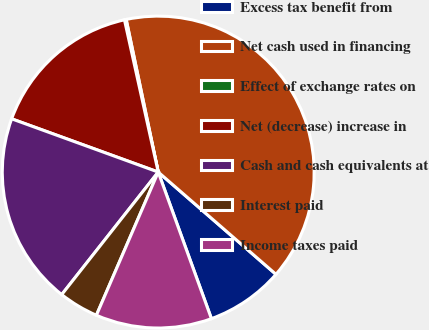Convert chart to OTSL. <chart><loc_0><loc_0><loc_500><loc_500><pie_chart><fcel>Excess tax benefit from<fcel>Net cash used in financing<fcel>Effect of exchange rates on<fcel>Net (decrease) increase in<fcel>Cash and cash equivalents at<fcel>Interest paid<fcel>Income taxes paid<nl><fcel>8.08%<fcel>39.68%<fcel>0.18%<fcel>15.98%<fcel>19.93%<fcel>4.13%<fcel>12.03%<nl></chart> 